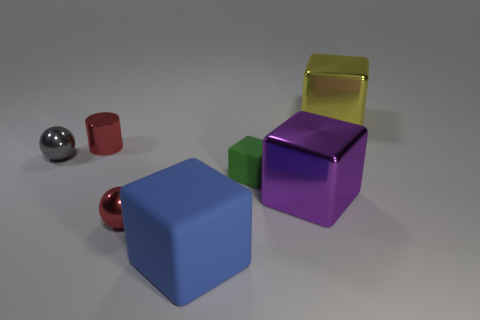Add 1 tiny cyan metal cubes. How many objects exist? 8 Subtract all balls. How many objects are left? 5 Subtract all tiny brown cylinders. Subtract all tiny shiny balls. How many objects are left? 5 Add 7 yellow cubes. How many yellow cubes are left? 8 Add 1 tiny blue matte cylinders. How many tiny blue matte cylinders exist? 1 Subtract 0 yellow cylinders. How many objects are left? 7 